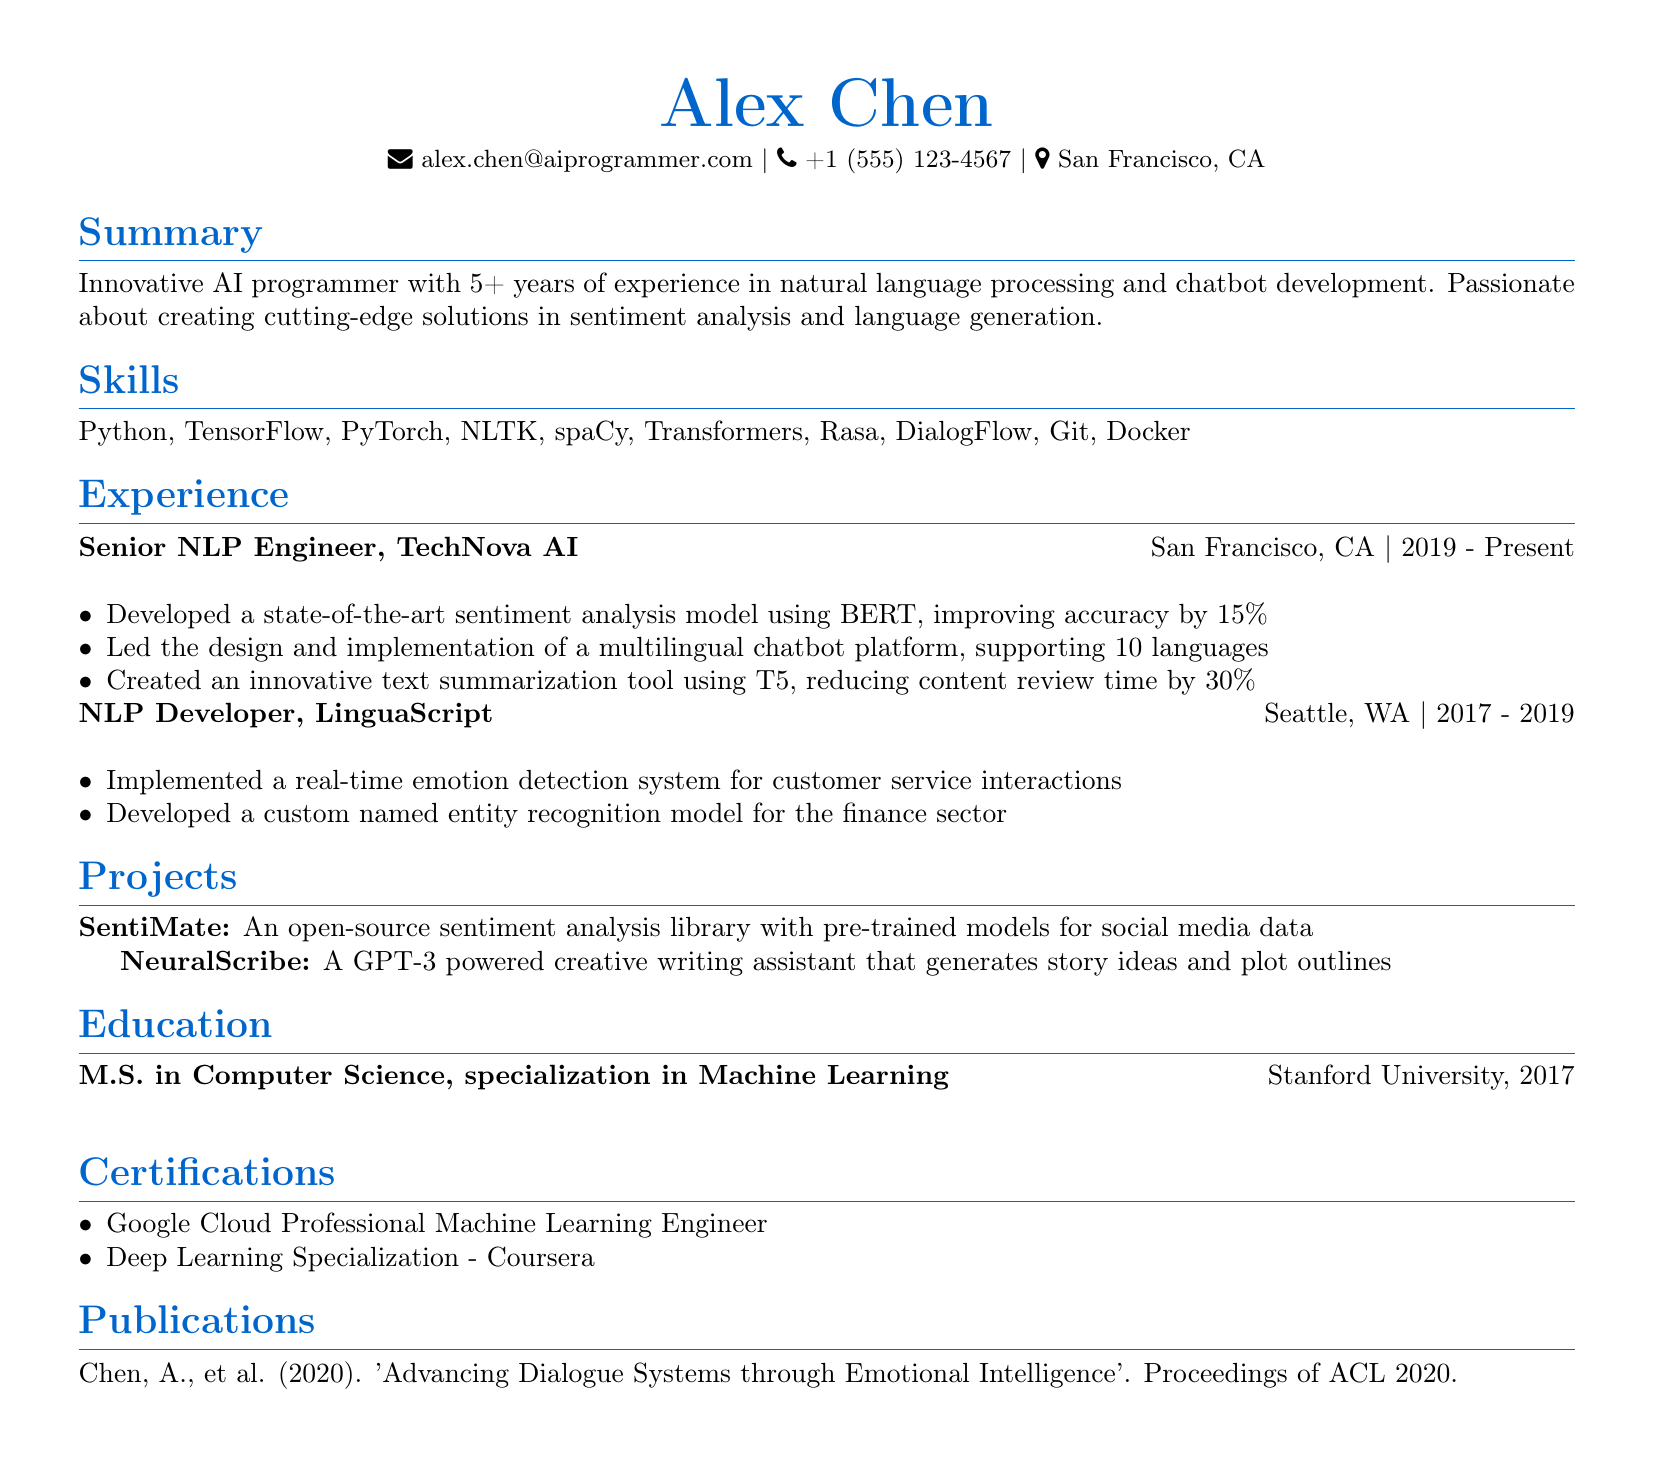What is the name of the candidate? The name is located at the top of the document under personal information.
Answer: Alex Chen What is the highest degree obtained? The education section specifies the degree earned by the candidate.
Answer: M.S. in Computer Science Which company did Alex work for as a Senior NLP Engineer? The experience section shows Alex's job title along with the associated company name.
Answer: TechNova AI How many years of experience does Alex have in AI programming? The summary section provides the total years of experience mentioned by the candidate.
Answer: 5+ What was the duration of Alex's tenure at LinguaScript? The experience section lists the employment duration for Alex at that position.
Answer: 2017 - 2019 What is the focus of the project "NeuralScribe"? The projects section provides a brief description of what the project entails.
Answer: Creative writing assistant Which certification is from Google? The certifications section will indicate which one is issued by Google.
Answer: Google Cloud Professional Machine Learning Engineer How much did the sentiment analysis model's accuracy improve by? The achievement details under TechNova AI provide this specific improvement figure.
Answer: 15% What technology does Alex use for chatbot development? The skills section lists technologies relevant to the candidate's expertise including chatbot development.
Answer: Rasa 